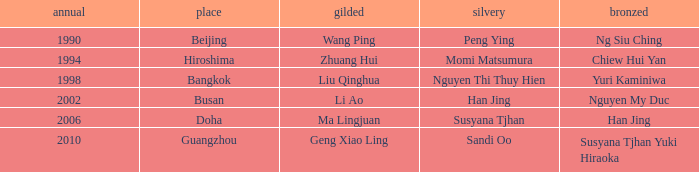What's the lowest Year with the Location of Bangkok? 1998.0. 